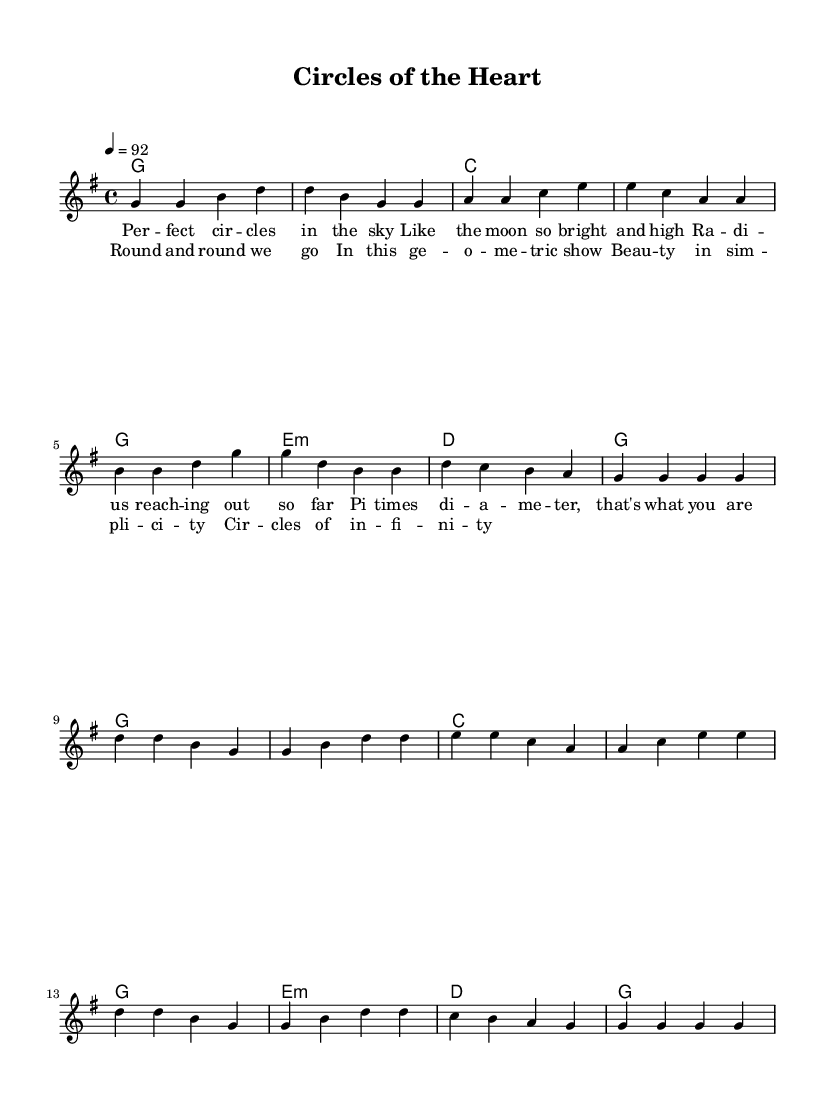What is the key signature of this music? The key signature is G major, which has one sharp (F#).
Answer: G major What is the time signature of this piece? The time signature is 4/4, indicating four beats per measure.
Answer: 4/4 What is the tempo marking for this song? The tempo marking indicates a tempo of 92 beats per minute.
Answer: 92 How many measures are there in the verse? The verse contains eight measures, as indicated by the line breaks in the melody section.
Answer: Eight What is the first lyric of the chorus? The first lyric of the chorus is "Round," which is visible at the beginning of the chorus lyrics.
Answer: Round How does the harmony change between the verse and chorus? The harmony remains consistent in structure but switches from the verse's G major to the chorus's emphasis on the same chord progressions, maintaining the G major tonality.
Answer: Consistent structure What geometrical shape is notably mentioned in the lyrics? The lyrics reference "circles," connecting the theme of geometric shapes within the context of the song.
Answer: Circles 